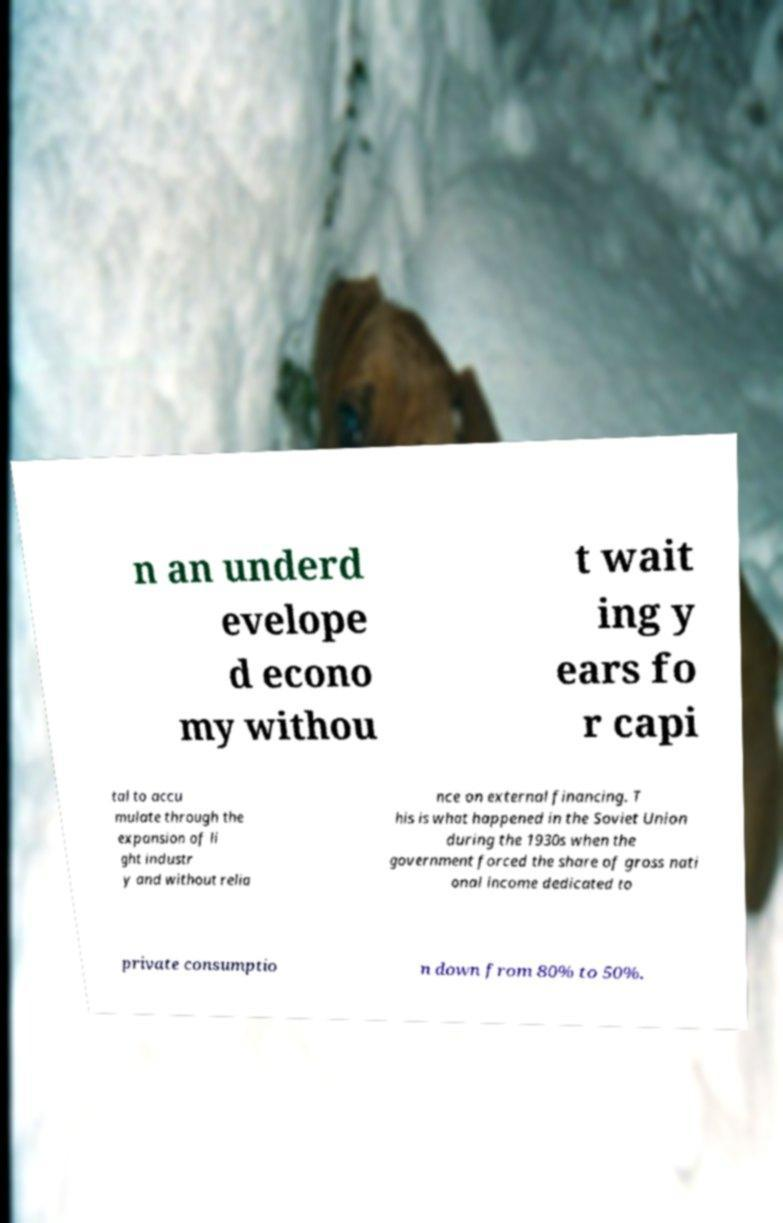Could you extract and type out the text from this image? n an underd evelope d econo my withou t wait ing y ears fo r capi tal to accu mulate through the expansion of li ght industr y and without relia nce on external financing. T his is what happened in the Soviet Union during the 1930s when the government forced the share of gross nati onal income dedicated to private consumptio n down from 80% to 50%. 